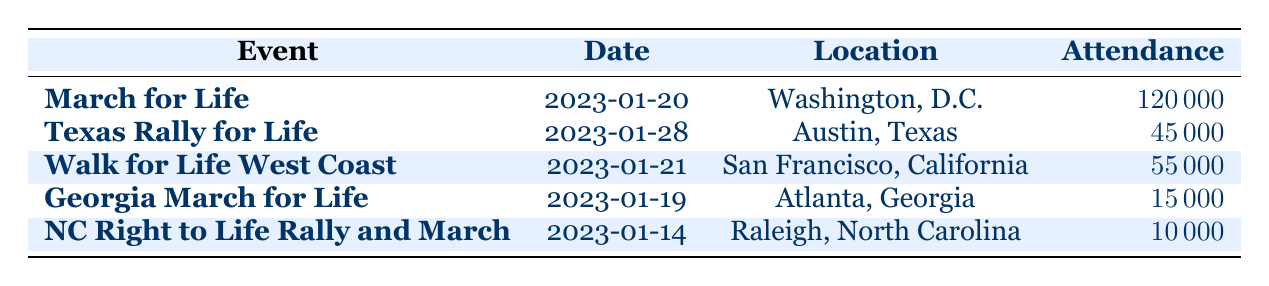What is the date of the Texas Rally for Life? The table lists the Texas Rally for Life with its corresponding date, which is explicitly stated as January 28, 2023.
Answer: January 28, 2023 How many attendees were at the March for Life? From the table, the attendance for the March for Life event is shown to be 120,000.
Answer: 120,000 Which event had the lowest attendance? By examining the attendance figures in the table, the event with the lowest attendance is the North Carolina Right to Life Rally and March, which had 10,000 attendees.
Answer: North Carolina Right to Life Rally and March What is the total attendance of all events combined? To find the total attendance, we need to add each event's attendance: 120,000 + 45,000 + 55,000 + 15,000 + 10,000 = 245,000.
Answer: 245,000 Did the Georgia March for Life receive more total donations than the Texas Rally for Life? The table shows that the total donations for the Georgia March for Life were $50,000, while for the Texas Rally for Life, they were $150,000. Therefore, the Georgia March for Life did not receive more donations.
Answer: No What is the average attendance of the rallies listed in the table? First, we calculate the total attendance: 120,000 (March for Life) + 45,000 (Texas Rally for Life) + 55,000 (Walk for Life West Coast) + 15,000 (Georgia March for Life) + 10,000 (North Carolina Rally) = 245,000. Then, we divide by the number of events (5): 245,000 / 5 = 49,000.
Answer: 49,000 How much did the Knights of Columbus donate? According to the table, the Knights of Columbus contributed $60,000 to the March for Life event.
Answer: $60,000 Which event had the highest total donations? By reviewing the total donations in the table, the March for Life had the highest total donations of $400,000 compared to the other events.
Answer: March for Life Is there an event in California listed in the table? The table includes the Walk for Life West Coast, which is located in San Francisco, California. Therefore, the answer is yes.
Answer: Yes 